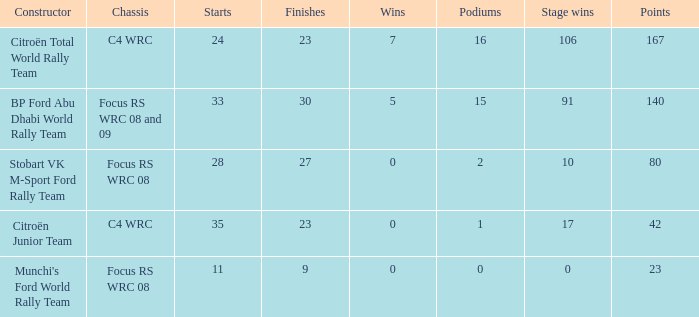What is the average wins when the podiums is more than 1, points is 80 and starts is less than 28? None. 